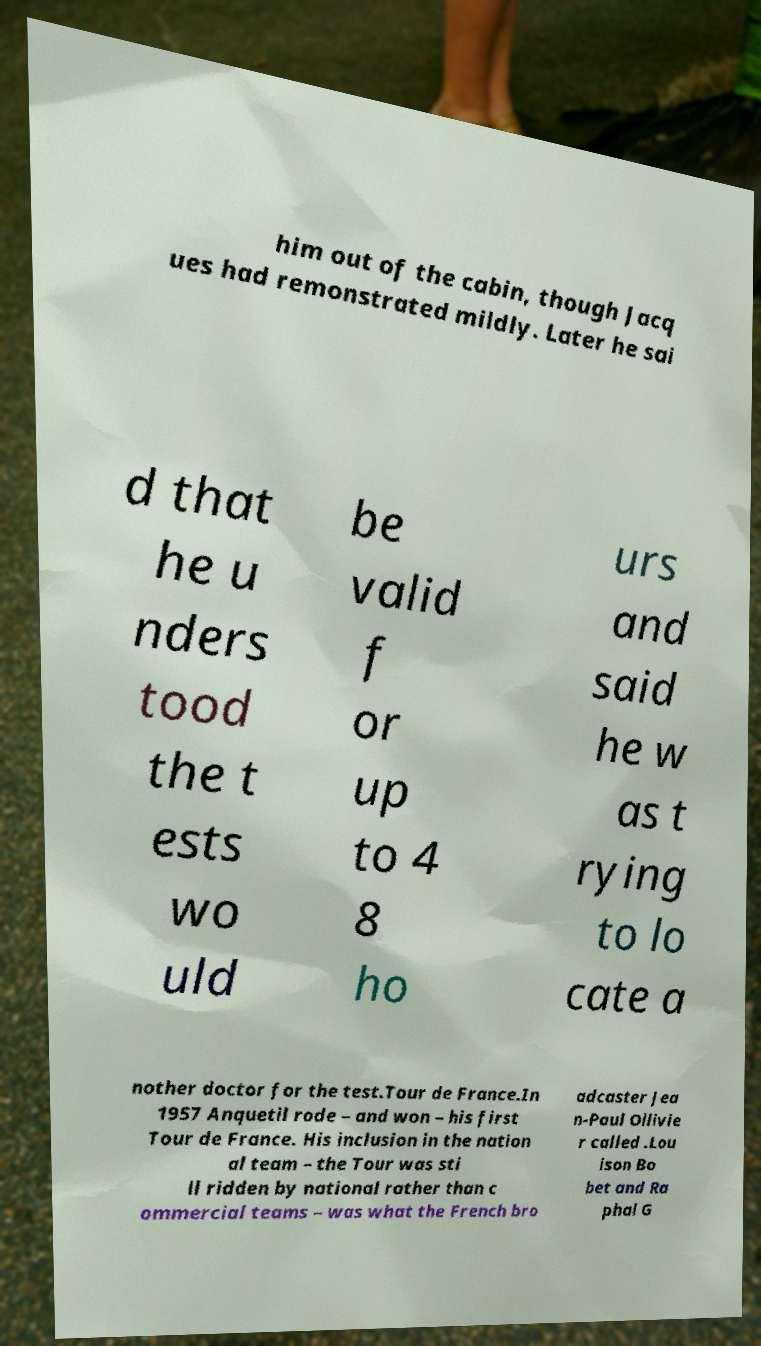Could you assist in decoding the text presented in this image and type it out clearly? him out of the cabin, though Jacq ues had remonstrated mildly. Later he sai d that he u nders tood the t ests wo uld be valid f or up to 4 8 ho urs and said he w as t rying to lo cate a nother doctor for the test.Tour de France.In 1957 Anquetil rode – and won – his first Tour de France. His inclusion in the nation al team – the Tour was sti ll ridden by national rather than c ommercial teams – was what the French bro adcaster Jea n-Paul Ollivie r called .Lou ison Bo bet and Ra phal G 